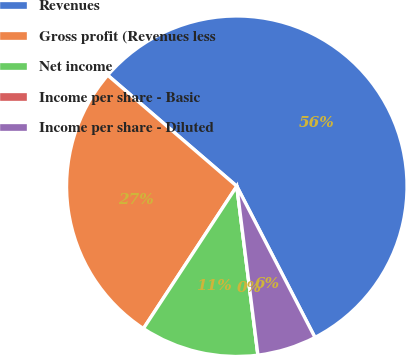Convert chart to OTSL. <chart><loc_0><loc_0><loc_500><loc_500><pie_chart><fcel>Revenues<fcel>Gross profit (Revenues less<fcel>Net income<fcel>Income per share - Basic<fcel>Income per share - Diluted<nl><fcel>56.1%<fcel>27.06%<fcel>11.22%<fcel>0.0%<fcel>5.61%<nl></chart> 